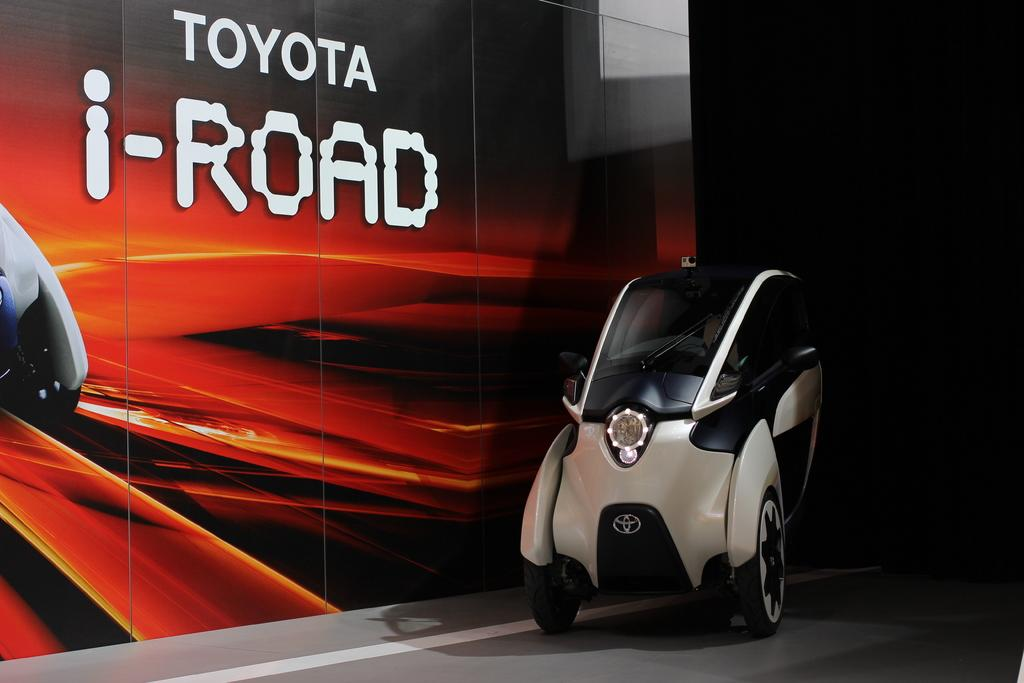What is the main object in the image? There is a machine in the image. Where is the machine located? The machine is on a path. What can be seen behind the machine? There is a wall behind the machine. What color is the orange on top of the machine in the image? There is no orange present on top of the machine in the image. 